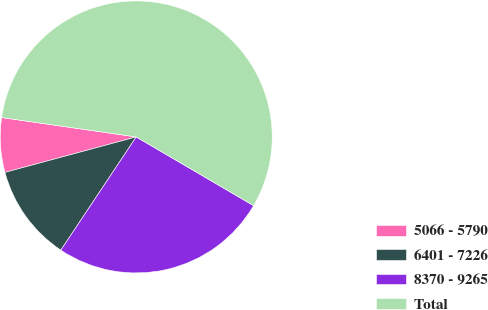Convert chart. <chart><loc_0><loc_0><loc_500><loc_500><pie_chart><fcel>5066 - 5790<fcel>6401 - 7226<fcel>8370 - 9265<fcel>Total<nl><fcel>6.48%<fcel>11.45%<fcel>25.92%<fcel>56.16%<nl></chart> 